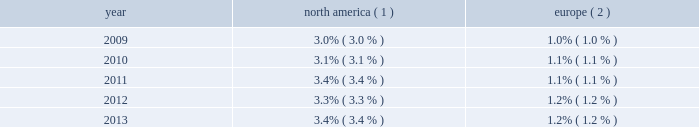Pullmantur during 2013 , we operated four ships with an aggre- gate capacity of approximately 7650 berths under our pullmantur brand , offering cruise itineraries that ranged from four to 12 nights throughout south america , the caribbean and europe .
One of these ships , zenith , was redeployed from pullmantur to cdf croisi e8res de france in january 2014 .
Pullmantur serves the contemporary segment of the spanish , portuguese and latin american cruise markets .
Pullmantur 2019s strategy is to attract cruise guests from these target markets by providing a variety of cruising options and onboard activities directed at couples and families traveling with children .
Over the last few years , pullmantur has systematically increased its focus on latin america .
In recognition of this , pullmantur recently opened a regional head office in panama to place the operating management closer to its largest and fastest growing market .
In order to facilitate pullmantur 2019s ability to focus on its core cruise business , in december 2013 , pullmantur reached an agreement to sell the majority of its inter- est in its land-based tour operations , travel agency and pullmantur air , the closing of which is subject to customary closing conditions .
In connection with the agreement , we will retain a 19% ( 19 % ) interest in the non-core businesses .
We will retain ownership of the pullmantur aircraft which will be dry leased to pullmantur air .
Cdf croisi e8res de france in january 2014 , we redeployed zenith from pullmantur to cdf croisi e8res de france .
As a result , as of january 2014 , we operate two ships with an aggregate capac- ity of approximately 2750 berths under our cdf croisi e8res de france brand .
During the summer of 2014 , cdf croisi e8res de france will operate both ships in europe and , for the first time , the brand will operate in the caribbean during the winter of 2014 .
In addition , cdf croisi e8res de france offers seasonal itineraries to the mediterranean .
Cdf croisi e8res de france is designed to serve the contemporary seg- ment of the french cruise market by providing a brand tailored for french cruise guests .
Tui cruises tui cruises is designed to serve the contemporary and premium segments of the german cruise market by offering a product tailored for german guests .
All onboard activities , services , shore excursions and menu offerings are designed to suit the preferences of this target market .
Tui cruises operates two ships , mein schiff 1 and mein schiff 2 , with an aggregate capacity of approximately 3800 berths .
In addition , tui cruises has two ships on order , each with a capacity of 2500 berths , scheduled for delivery in the second quarter of 2014 and second quarter of 2015 .
Tui cruises is a joint venture owned 50% ( 50 % ) by us and 50% ( 50 % ) by tui ag , a german tourism and shipping company that also owns 51% ( 51 % ) of tui travel , a british tourism company .
Industry cruising is considered a well-established vacation sector in the north american market , a growing sec- tor over the long-term in the european market and a developing but promising sector in several other emerging markets .
Industry data indicates that market penetration rates are still low and that a significant portion of cruise guests carried are first-time cruisers .
We believe this presents an opportunity for long-term growth and a potential for increased profitability .
The table details market penetration rates for north america and europe computed based on the number of annual cruise guests as a percentage of the total population : america ( 1 ) europe ( 2 ) .
( 1 ) source : international monetary fund and cruise line international association based on cruise guests carried for at least two con- secutive nights for years 2009 through 2012 .
Year 2013 amounts represent our estimates .
Includes the united states of america and canada .
( 2 ) source : international monetary fund and clia europe , formerly european cruise council , for years 2009 through 2012 .
Year 2013 amounts represent our estimates .
We estimate that the global cruise fleet was served by approximately 436000 berths on approximately 269 ships at the end of 2013 .
There are approximately 26 ships with an estimated 71000 berths that are expected to be placed in service in the global cruise market between 2014 and 2018 , although it is also possible that ships could be ordered or taken out of service during these periods .
We estimate that the global cruise industry carried 21.3 million cruise guests in 2013 compared to 20.9 million cruise guests carried in 2012 and 20.2 million cruise guests carried in 2011 .
Part i .
What is the anticipated increase to the global cruise fleet berths from 2014 - 2018? 
Computations: (71000 / 436000)
Answer: 0.16284. 